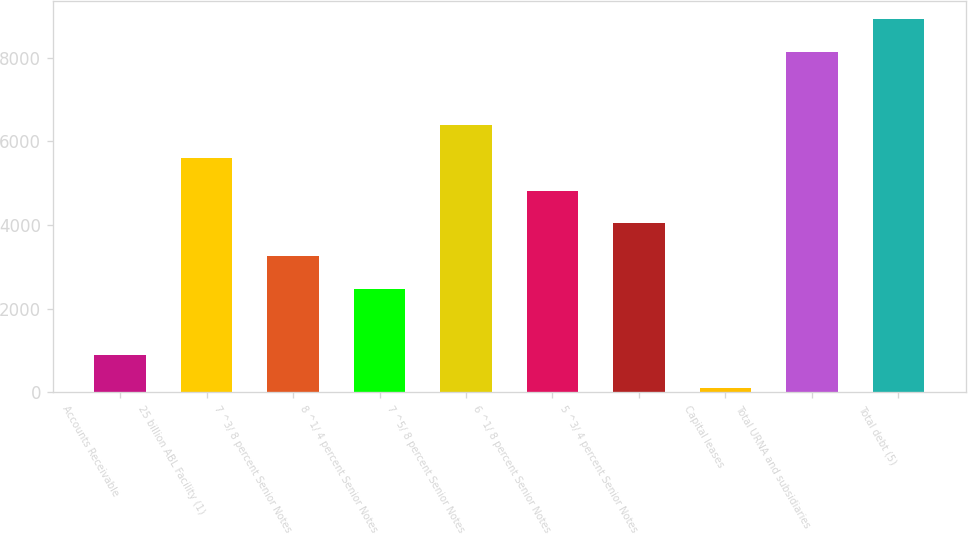<chart> <loc_0><loc_0><loc_500><loc_500><bar_chart><fcel>Accounts Receivable<fcel>25 billion ABL Facility (1)<fcel>7 ^3/ 8 percent Senior Notes<fcel>8 ^1/ 4 percent Senior Notes<fcel>7 ^5/ 8 percent Senior Notes<fcel>6 ^1/ 8 percent Senior Notes<fcel>5 ^3/ 4 percent Senior Notes<fcel>Capital leases<fcel>Total URNA and subsidiaries<fcel>Total debt (5)<nl><fcel>890.7<fcel>5604.9<fcel>3247.8<fcel>2462.1<fcel>6390.6<fcel>4819.2<fcel>4033.5<fcel>105<fcel>8129.7<fcel>8915.4<nl></chart> 